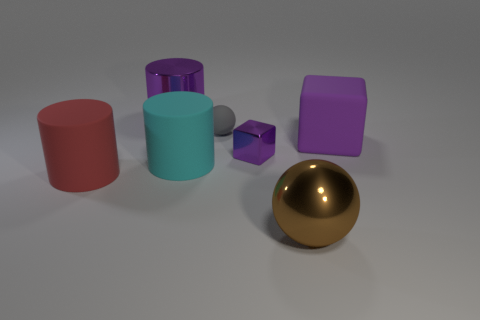Are there more large red matte objects than purple metallic objects?
Provide a succinct answer. No. What size is the purple shiny thing that is to the right of the ball on the left side of the large brown shiny object?
Make the answer very short. Small. What shape is the object that is the same size as the purple shiny block?
Ensure brevity in your answer.  Sphere. There is a large purple object that is on the left side of the brown ball that is in front of the shiny object behind the metallic block; what shape is it?
Ensure brevity in your answer.  Cylinder. Does the large rubber thing behind the cyan rubber cylinder have the same color as the metal object that is behind the tiny gray rubber sphere?
Offer a terse response. Yes. What number of tiny red matte balls are there?
Keep it short and to the point. 0. There is a brown metallic sphere; are there any metal things to the left of it?
Your answer should be very brief. Yes. Does the big thing in front of the large red object have the same material as the large cylinder right of the metal cylinder?
Offer a terse response. No. Is the number of big purple metallic things that are in front of the large red rubber thing less than the number of gray spheres?
Provide a succinct answer. Yes. What color is the sphere behind the metallic ball?
Give a very brief answer. Gray. 